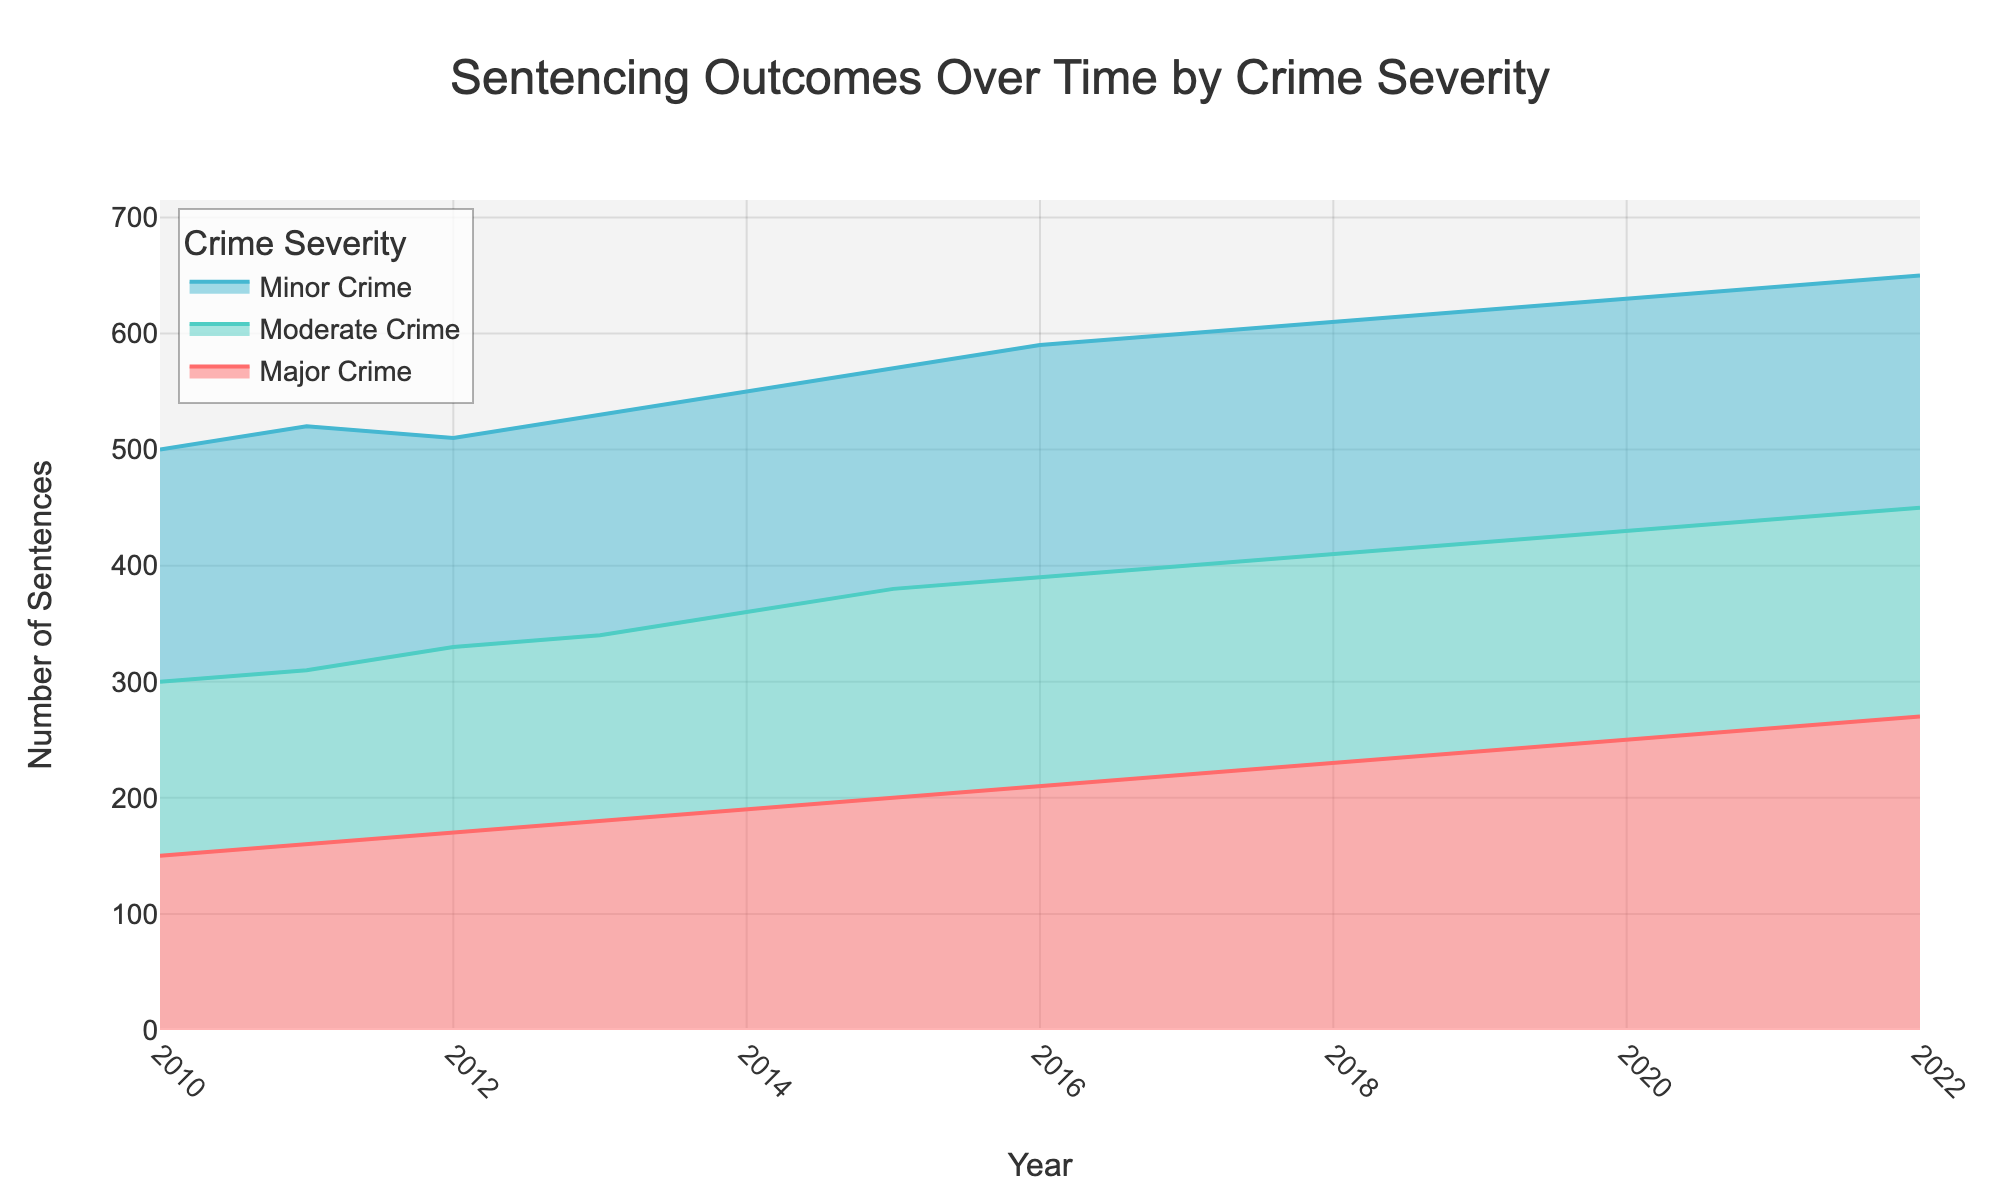What is the title of the chart? The title of the chart is prominently displayed at the top of the figure. It reads 'Sentencing Outcomes Over Time by Crime Severity'.
Answer: Sentencing Outcomes Over Time by Crime Severity How many years of data are presented in the chart? By looking at the x-axis, the chart shows data points from the year 2010 to the year 2022, covering 13 years.
Answer: 13 years What color is used to represent Moderate Crime in the chart? On the chart, the color legends clarify the representation. Moderate Crime is indicated by a teal-like color.
Answer: Teal-like What year had the highest number of sentences for Minor Crime? Observing the area representing Minor Crime, 2022 had the highest number of sentences, positioned at the peak of the blue area.
Answer: 2022 Which crime severity has the least visual area across all years? The smallest visual area is represented by the final and narrowest band at the top, which corresponds to Major Crime.
Answer: Major Crime What is the trend for Major Crime sentences over the years? Major Crime sentences display a rising trend. Observationally, each subsequent year has a higher area representation than the previous year.
Answer: Increasing trend What is the combined number of sentences for all crime severities in 2015? Summing the values for Minor, Moderate, and Major Crime in 2015: 570 (Minor) + 380 (Moderate) + 200 (Major) = 1150.
Answer: 1150 Comparing 2010 and 2022, how has Minor Crime changed? The area illustrating Minor Crime has increased from 500 in 2010 to 650 in 2022, showing a net increase of 150 sentences.
Answer: Increased by 150 Which crime severity had the smallest increase in sentences from 2010 to 2022? By evaluating the differences from 2010 to 2022 for each crime severity: Minor (150), Moderate (150), and Major (120). Major Crime showed the smallest increase.
Answer: Major Crime, 120 By what percentage did Moderate Crime sentences increase from 2010 to 2022? Calculating the percentage increase: ((450 - 300) / 300) * 100 = 50%.
Answer: 50% What are the visual differences in the trends of Moderate and Major Crime? Both crime severities have an increasing trend, but the rate increase for Moderate Crime is more gradual, while Major Crime shows a steadier linear inclination.
Answer: Both increase; Moderate more gradual, Major steadier 